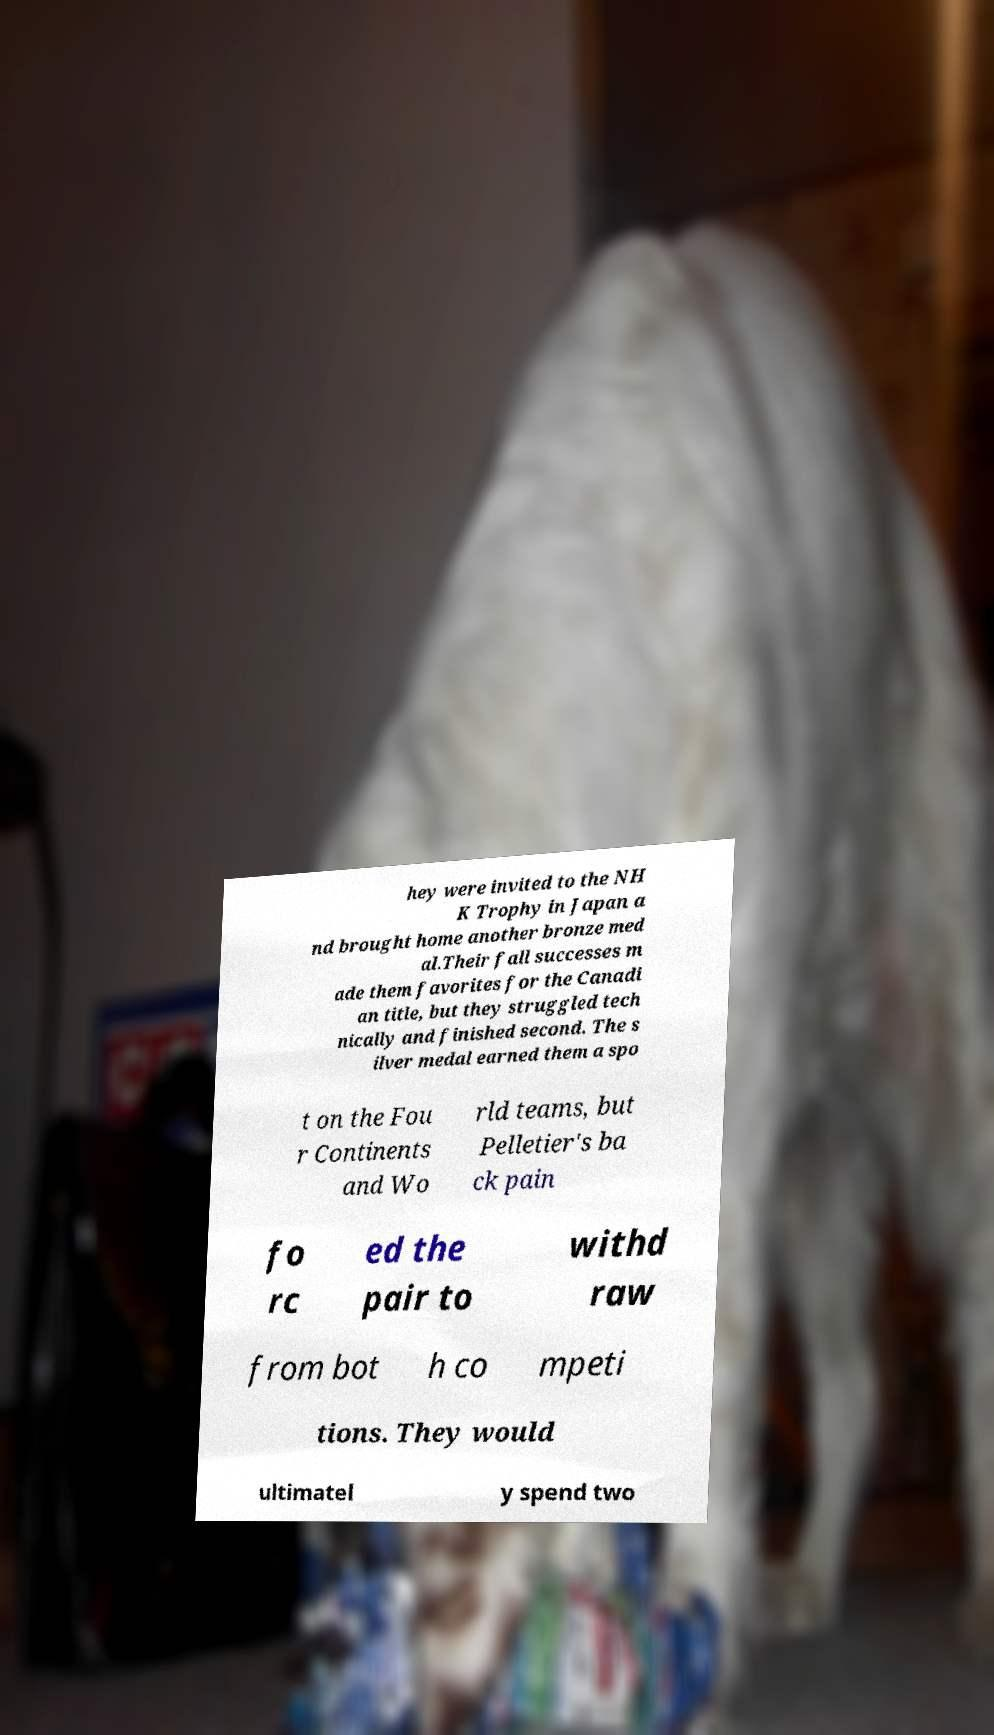What messages or text are displayed in this image? I need them in a readable, typed format. hey were invited to the NH K Trophy in Japan a nd brought home another bronze med al.Their fall successes m ade them favorites for the Canadi an title, but they struggled tech nically and finished second. The s ilver medal earned them a spo t on the Fou r Continents and Wo rld teams, but Pelletier's ba ck pain fo rc ed the pair to withd raw from bot h co mpeti tions. They would ultimatel y spend two 